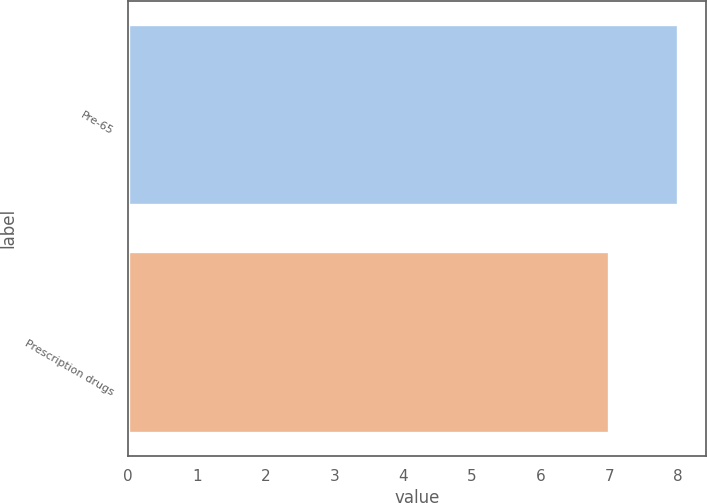Convert chart to OTSL. <chart><loc_0><loc_0><loc_500><loc_500><bar_chart><fcel>Pre-65<fcel>Prescription drugs<nl><fcel>8<fcel>7<nl></chart> 